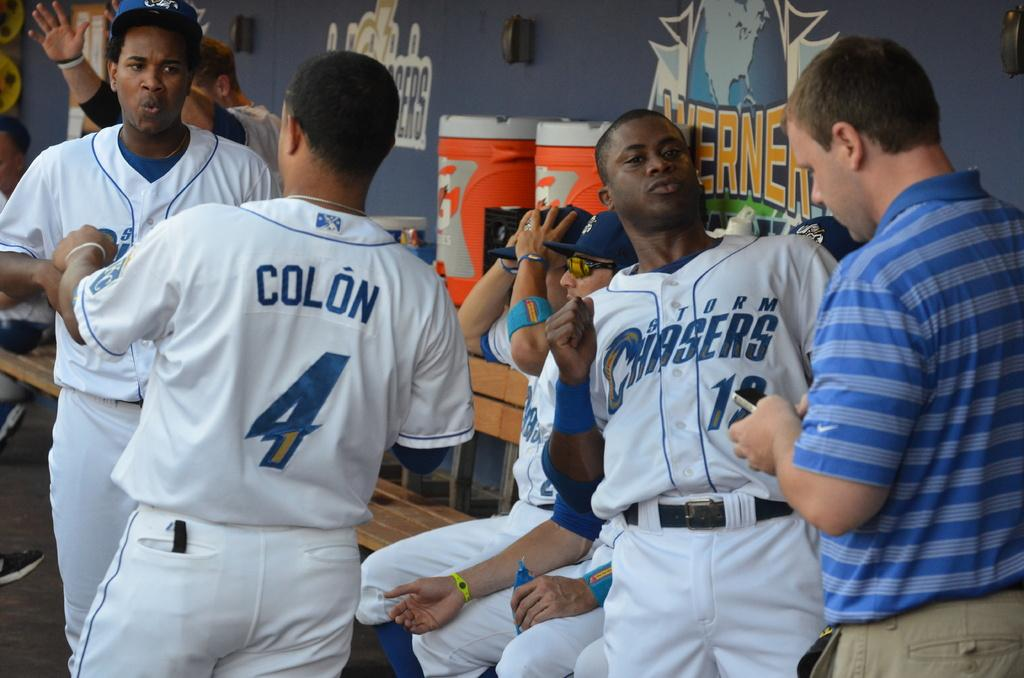Provide a one-sentence caption for the provided image. A group of baseball players  1 sitting down 4 standing up 2 of the standing  baseball players are talking to each other. 